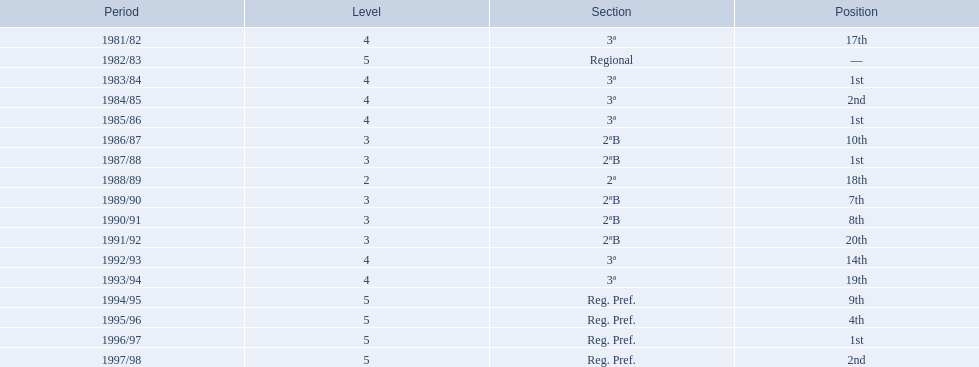What is the lowest place the team has come out? 20th. In what year did they come out in 20th place? 1991/92. 